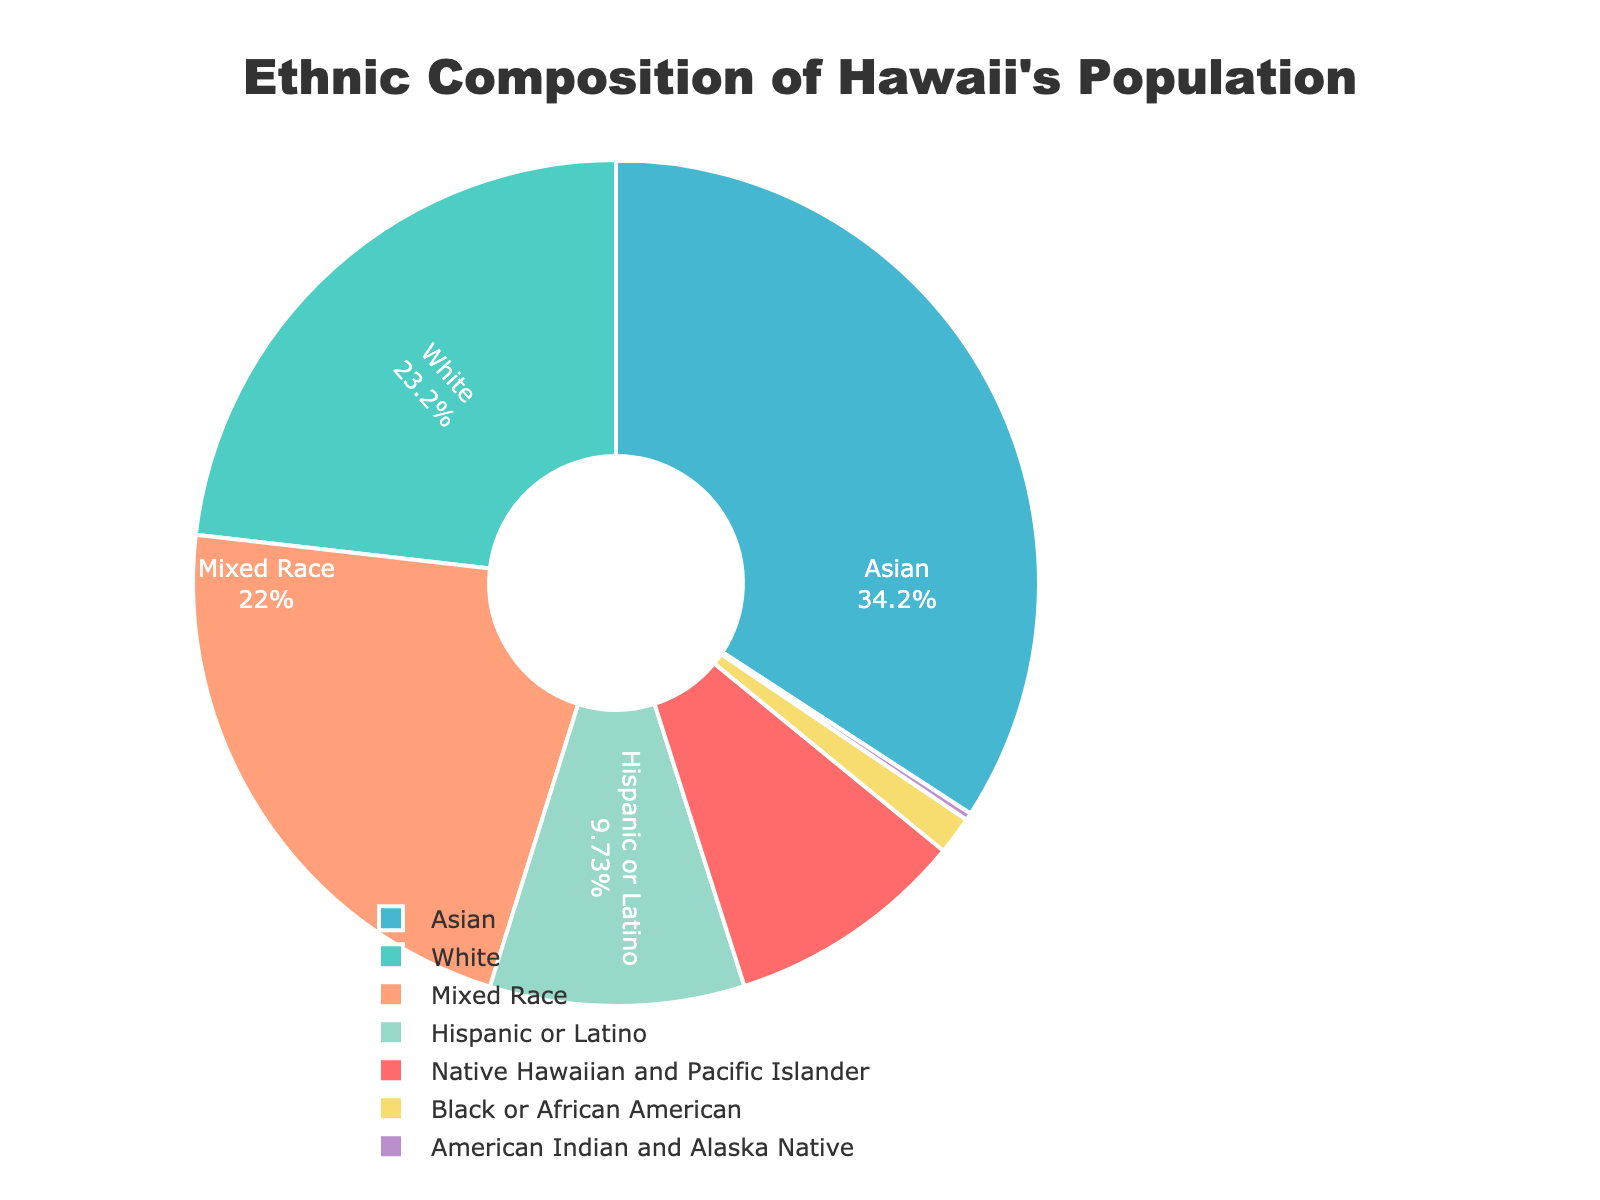What is the percentage of the Asian population in Hawaii? Look at the pie chart segment labeled "Asian" and refer to the percentage value displayed.
Answer: 37.6% Which ethnic group comprises the smallest percentage of Hawaii's population? Identify the segment with the smallest numeric percentage value.
Answer: American Indian and Alaska Native What is the combined percentage of Native Hawaiian and Pacific Islander and Hispanic or Latino populations? Add the percentage values for "Native Hawaiian and Pacific Islander" (10.1%) and "Hispanic or Latino" (10.7%). 10.1 + 10.7 = 20.8
Answer: 20.8% Is the percentage of the Mixed Race population higher than the percentage of the White population? Compare the percentages given for "Mixed Race" (24.2%) and "White" (25.5%). 24.2 is less than 25.5, so Mixed Race is not higher.
Answer: No What is the median percentage among all ethnic groups listed? Arrange the percentages in ascending order: 0.3, 1.6, 10.1, 10.7, 24.2, 25.5, 37.6. The median is the middle number, so it is 10.7 (Hispanic or Latino).
Answer: 10.7% Compare the percentage of Native Hawaiian and Pacific Islander to Black or African American. Which is greater and by how much? Subtract the percentage of Black or African American (1.6%) from Native Hawaiian and Pacific Islander (10.1%). 10.1 - 1.6 = 8.5. So, Native Hawaiian and Pacific Islander is greater by 8.5%.
Answer: Native Hawaiian and Pacific Islander by 8.5% What color represents the White population in the pie chart? Identify the segment of the pie chart labeled "White" and note its color.
Answer: Cyan What is the average percentage of all the ethnic groups combined? Add all the percentages: 10.1+25.5+37.6+24.2+10.7+1.6+0.3 = 110. Then divide by the number of groups, which is 7. 110 / 7 = ~15.71
Answer: ~15.71% If you combine the Asian and Mixed Race populations, what percentage of Hawaii's population does this represent? Add the percentages for "Asian" (37.6%) and "Mixed Race" (24.2%). 37.6 + 24.2 = 61.8
Answer: 61.8% How does the percentage of White populations compare to the overall population excluding itself? The percentage of the White population is 25.5%. To find the population excluding White, subtract 25.5 from 100, making it 74.5%. White populations compare as part of a whole percentage, being less than the other group by 49%
Answer: Less by 49% 